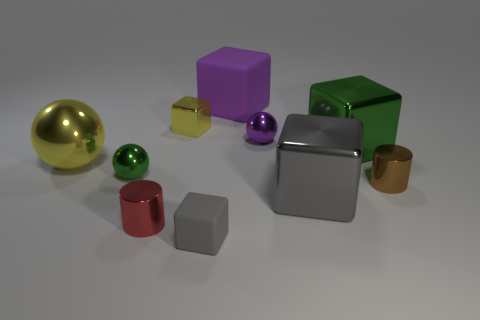There is a large green object that is to the left of the tiny brown thing; what number of gray shiny cubes are on the right side of it?
Provide a succinct answer. 0. What shape is the small yellow object that is made of the same material as the big gray thing?
Make the answer very short. Cube. How many blue objects are either small metal cubes or large metallic balls?
Offer a terse response. 0. Is there a gray block in front of the gray cube right of the metallic ball to the right of the small yellow metal cube?
Keep it short and to the point. Yes. Is the number of purple rubber objects less than the number of gray metal cylinders?
Offer a very short reply. No. There is a rubber object on the left side of the purple matte thing; is it the same shape as the small green metal object?
Offer a terse response. No. Is there a yellow cube?
Ensure brevity in your answer.  Yes. What is the color of the metal cylinder that is to the right of the matte object behind the tiny ball on the right side of the purple rubber object?
Keep it short and to the point. Brown. Is the number of balls that are in front of the yellow cube the same as the number of big yellow objects behind the brown metallic cylinder?
Your answer should be compact. No. There is a brown thing that is the same size as the purple ball; what shape is it?
Your answer should be compact. Cylinder. 